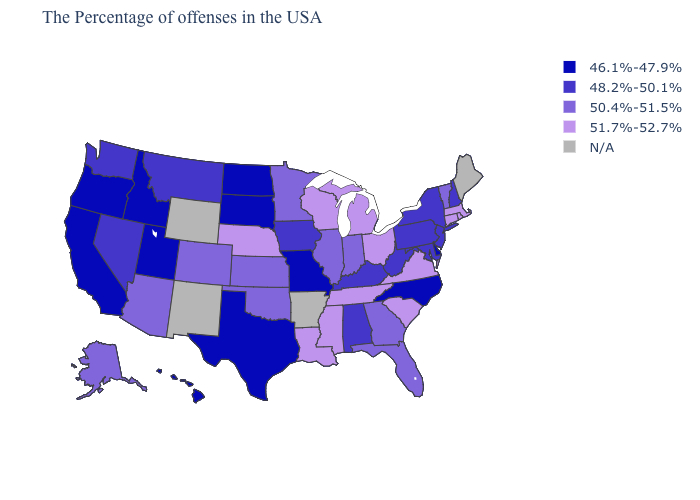What is the value of Wisconsin?
Answer briefly. 51.7%-52.7%. How many symbols are there in the legend?
Concise answer only. 5. Which states hav the highest value in the Northeast?
Quick response, please. Massachusetts, Rhode Island, Connecticut. What is the highest value in the USA?
Write a very short answer. 51.7%-52.7%. What is the value of Texas?
Answer briefly. 46.1%-47.9%. Which states have the highest value in the USA?
Concise answer only. Massachusetts, Rhode Island, Connecticut, Virginia, South Carolina, Ohio, Michigan, Tennessee, Wisconsin, Mississippi, Louisiana, Nebraska. Does New York have the lowest value in the USA?
Answer briefly. No. Among the states that border Connecticut , does New York have the lowest value?
Short answer required. Yes. Does Oregon have the highest value in the USA?
Answer briefly. No. What is the value of Illinois?
Short answer required. 50.4%-51.5%. Which states have the highest value in the USA?
Keep it brief. Massachusetts, Rhode Island, Connecticut, Virginia, South Carolina, Ohio, Michigan, Tennessee, Wisconsin, Mississippi, Louisiana, Nebraska. Which states have the highest value in the USA?
Give a very brief answer. Massachusetts, Rhode Island, Connecticut, Virginia, South Carolina, Ohio, Michigan, Tennessee, Wisconsin, Mississippi, Louisiana, Nebraska. Among the states that border Wisconsin , which have the lowest value?
Write a very short answer. Iowa. 